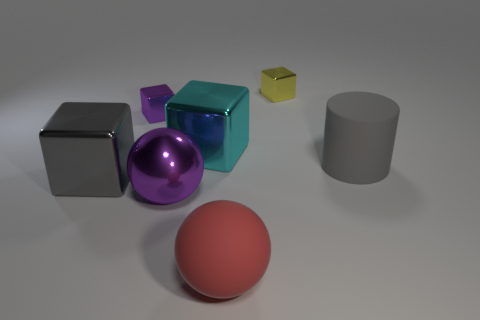Add 3 big matte cylinders. How many objects exist? 10 Subtract all cylinders. How many objects are left? 6 Subtract all tiny metal blocks. Subtract all large gray cylinders. How many objects are left? 4 Add 5 tiny purple objects. How many tiny purple objects are left? 6 Add 3 shiny objects. How many shiny objects exist? 8 Subtract 0 yellow balls. How many objects are left? 7 